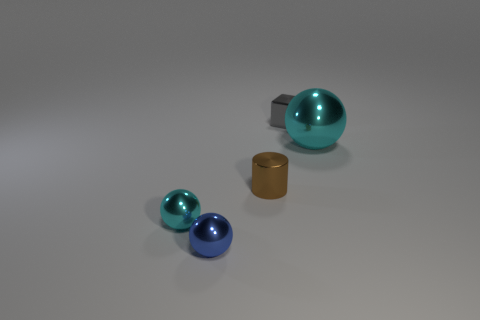Does the tiny gray shiny thing have the same shape as the metal thing to the right of the cube?
Offer a terse response. No. There is a object in front of the cyan sphere that is on the left side of the gray cube; is there a small blue thing that is behind it?
Your response must be concise. No. What is the size of the cyan metal thing right of the brown shiny cylinder?
Provide a succinct answer. Large. There is a brown thing that is the same size as the gray cube; what is it made of?
Provide a short and direct response. Metal. Do the blue metal object and the small cyan metallic object have the same shape?
Your response must be concise. Yes. How many objects are either matte objects or tiny cyan metallic spheres in front of the tiny brown thing?
Your response must be concise. 1. There is a object that is the same color as the large ball; what is it made of?
Your response must be concise. Metal. There is a thing that is right of the shiny block; is its size the same as the tiny cyan metallic sphere?
Give a very brief answer. No. What number of blue metallic balls are to the left of the cyan object behind the cyan metal sphere that is to the left of the small metallic block?
Ensure brevity in your answer.  1. What number of brown things are either metallic objects or tiny metal spheres?
Your answer should be very brief. 1. 